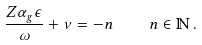<formula> <loc_0><loc_0><loc_500><loc_500>\frac { Z \alpha _ { g } \epsilon } { \omega } + \nu = - n \quad n \in \mathbb { N } \, .</formula> 